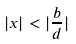Convert formula to latex. <formula><loc_0><loc_0><loc_500><loc_500>| x | < | \frac { b } { d } |</formula> 